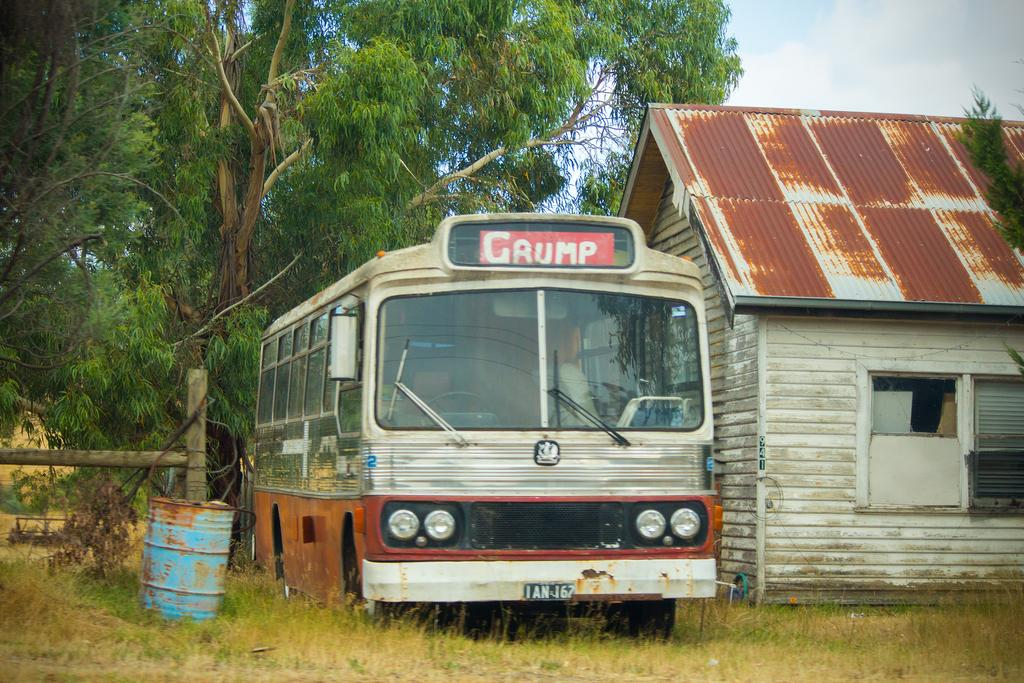<image>
Provide a brief description of the given image. An old bus with a sign on the top that says "Grump" next to a shed with a metal roof. 